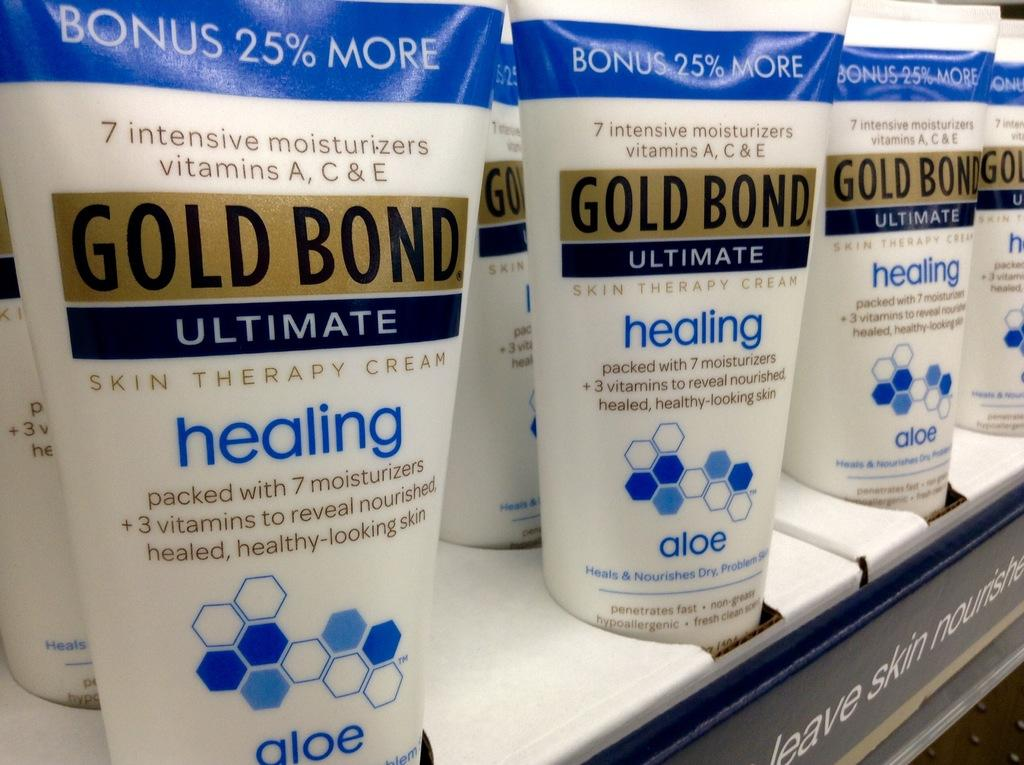<image>
Write a terse but informative summary of the picture. A shelf of Gold Bond ultimate healing lotion 